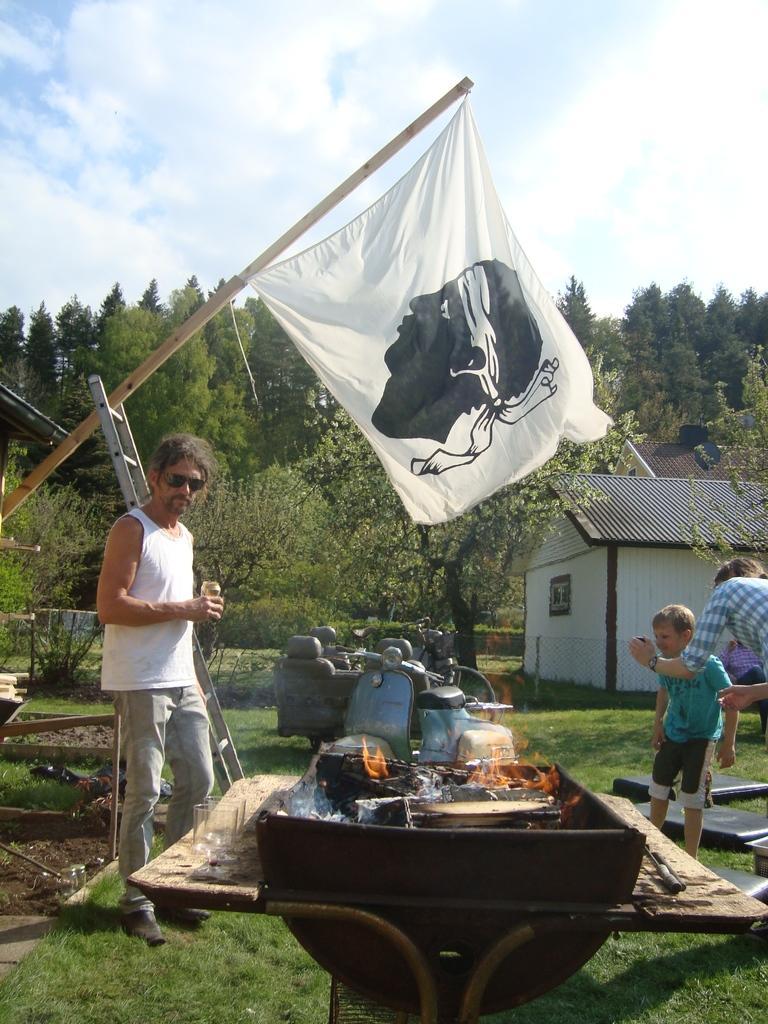How would you summarize this image in a sentence or two? In this image we can see few people, a person is holding a tin and a person is holding an object, there are few objects on the grass and there is an object with fire, there are glasses on the table, there is a flag, ladder, vehicles, there are buildings, trees and the sky in the background. 